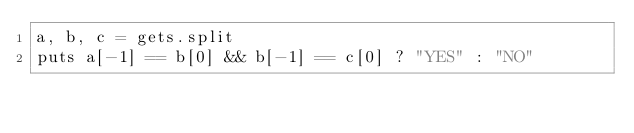<code> <loc_0><loc_0><loc_500><loc_500><_Ruby_>a, b, c = gets.split
puts a[-1] == b[0] && b[-1] == c[0] ? "YES" : "NO"</code> 